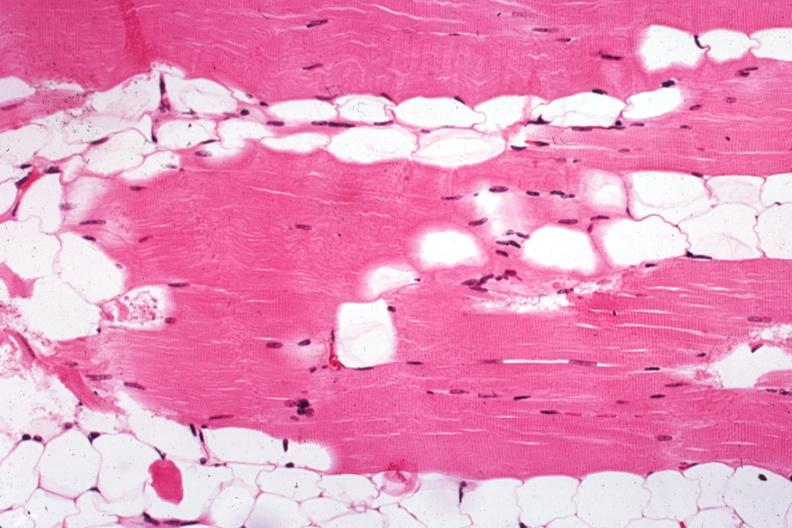what is present?
Answer the question using a single word or phrase. Muscle 